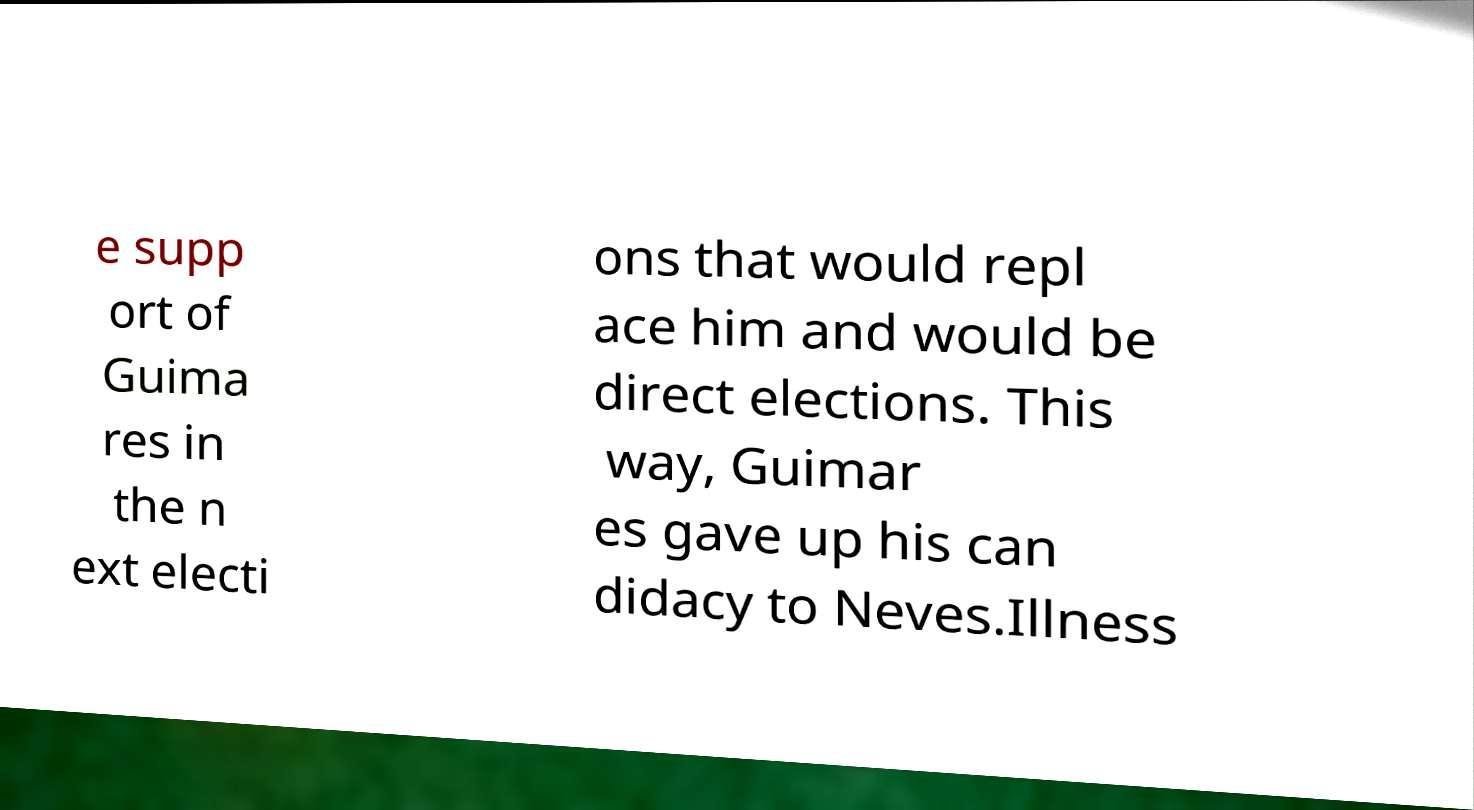Could you assist in decoding the text presented in this image and type it out clearly? e supp ort of Guima res in the n ext electi ons that would repl ace him and would be direct elections. This way, Guimar es gave up his can didacy to Neves.Illness 